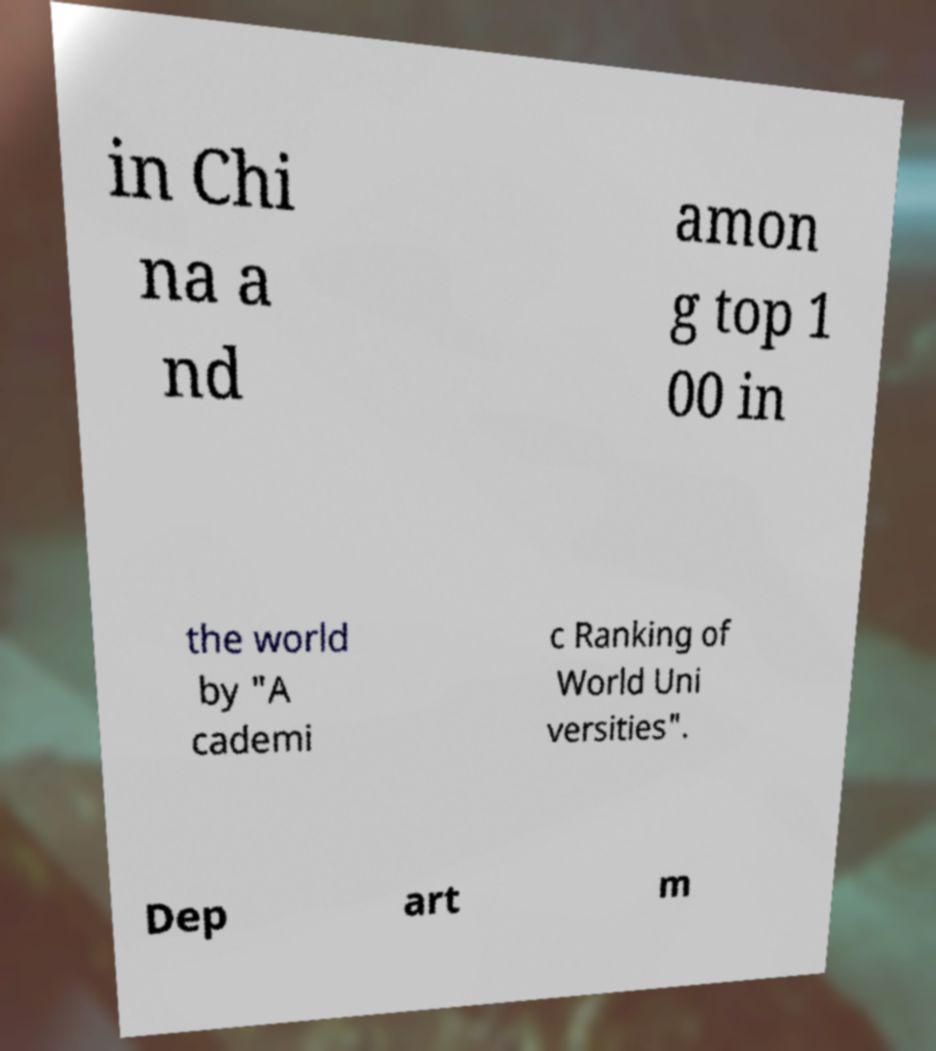What messages or text are displayed in this image? I need them in a readable, typed format. in Chi na a nd amon g top 1 00 in the world by "A cademi c Ranking of World Uni versities". Dep art m 